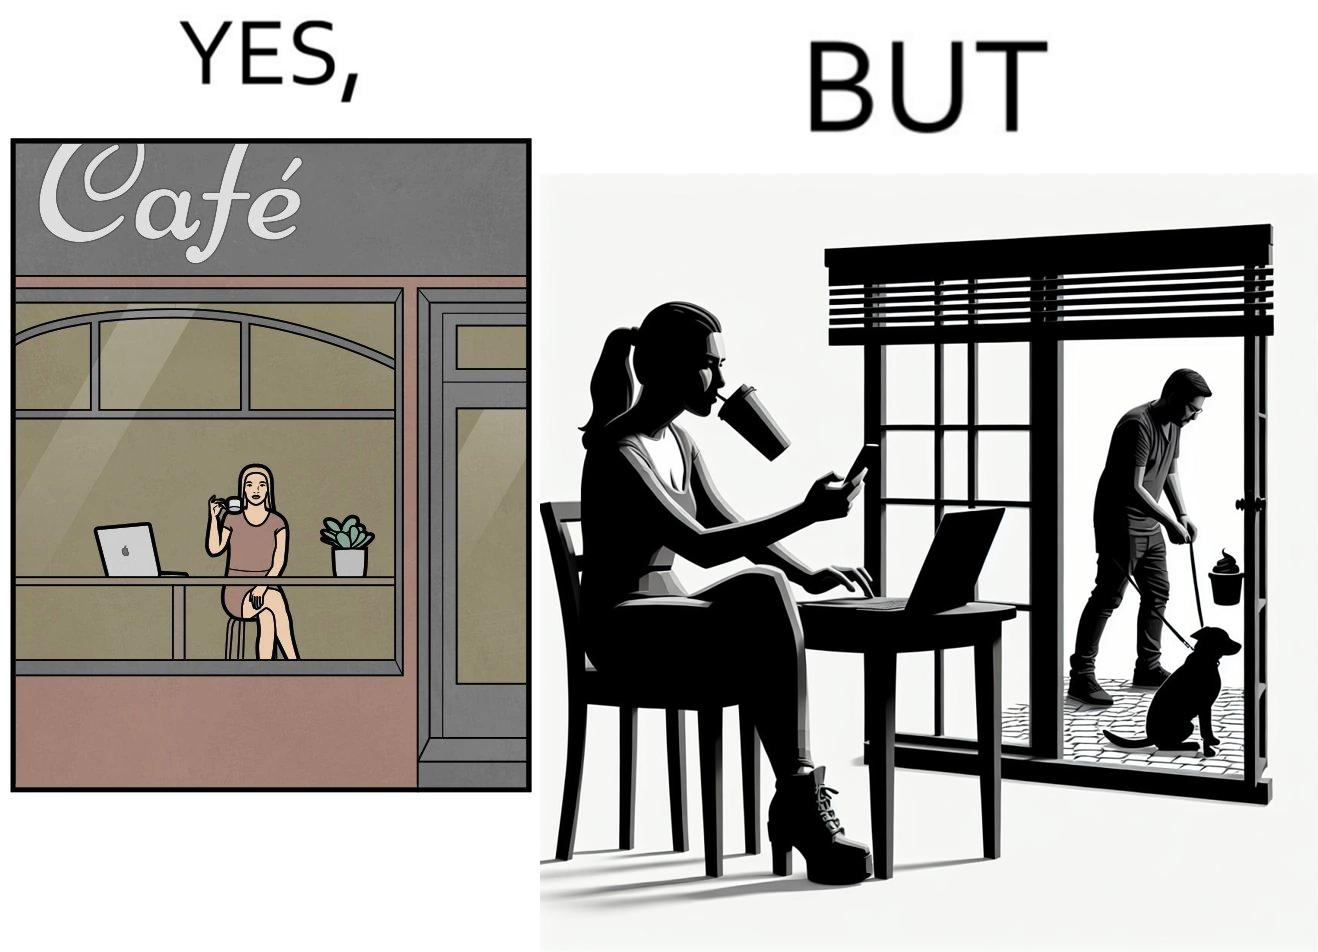Provide a description of this image. The image is ironic, because in the first image the woman is seen as enjoying the view but in the second image the same woman is seen as looking at a pooping dog 